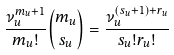<formula> <loc_0><loc_0><loc_500><loc_500>\frac { \nu ^ { m _ { u } + 1 } _ { u } } { m _ { u } ! } \binom { m _ { u } } { s _ { u } } = \frac { \nu _ { u } ^ { ( s _ { u } + 1 ) + r _ { u } } } { s _ { u } ! r _ { u } ! }</formula> 